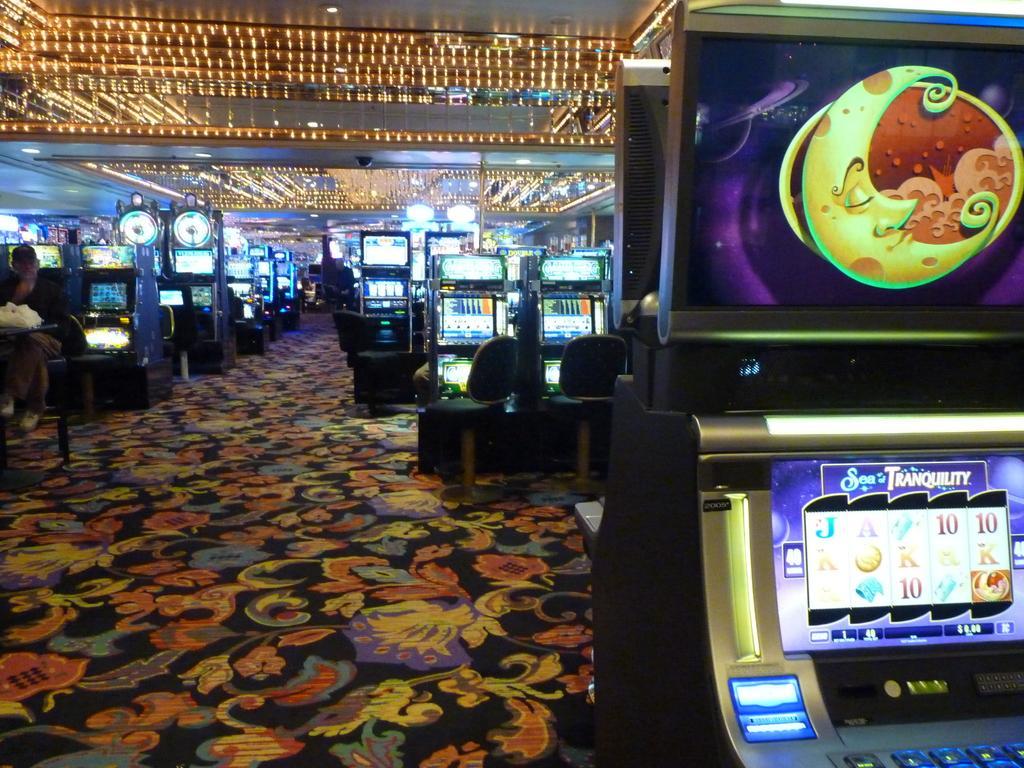Can you describe this image briefly? In this picture we can see the inside view of the casino. In front there is a card playing machine. Behind there are many machine and on the top there is a yellow color decorative lights. On the front bottom side there is a colorful carpet flooring. 